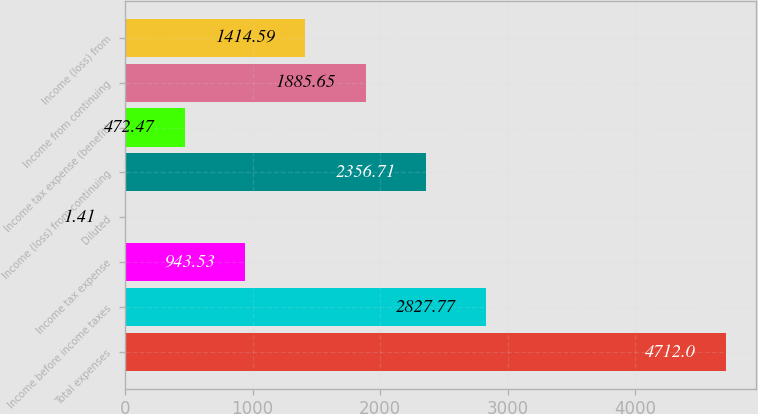Convert chart. <chart><loc_0><loc_0><loc_500><loc_500><bar_chart><fcel>Total expenses<fcel>Income before income taxes<fcel>Income tax expense<fcel>Diluted<fcel>Income (loss) from continuing<fcel>Income tax expense (benefit)<fcel>Income from continuing<fcel>Income (loss) from<nl><fcel>4712<fcel>2827.77<fcel>943.53<fcel>1.41<fcel>2356.71<fcel>472.47<fcel>1885.65<fcel>1414.59<nl></chart> 